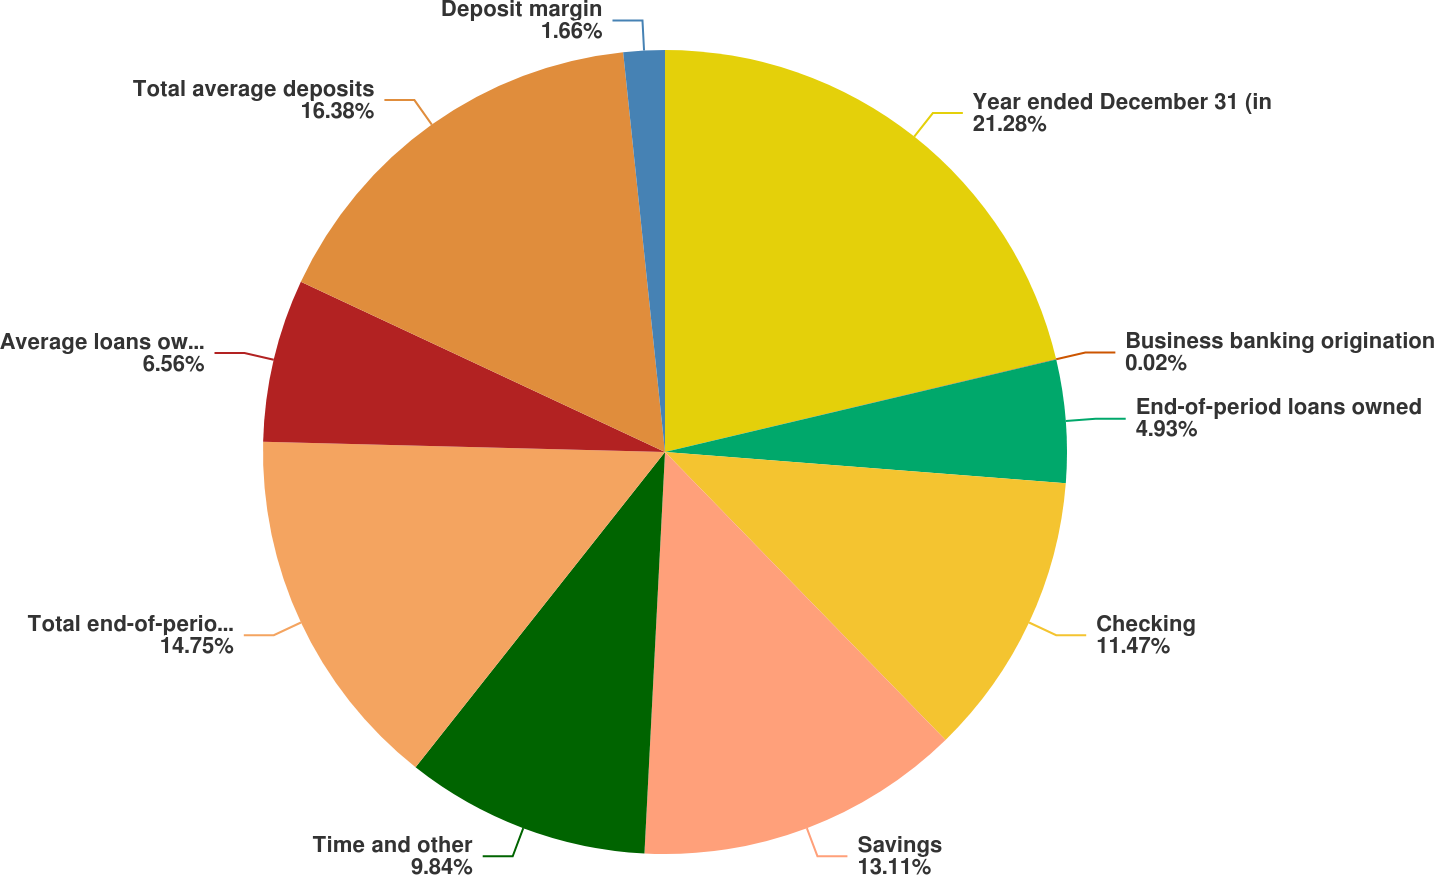Convert chart to OTSL. <chart><loc_0><loc_0><loc_500><loc_500><pie_chart><fcel>Year ended December 31 (in<fcel>Business banking origination<fcel>End-of-period loans owned<fcel>Checking<fcel>Savings<fcel>Time and other<fcel>Total end-of-period deposits<fcel>Average loans owned<fcel>Total average deposits<fcel>Deposit margin<nl><fcel>21.29%<fcel>0.02%<fcel>4.93%<fcel>11.47%<fcel>13.11%<fcel>9.84%<fcel>14.75%<fcel>6.56%<fcel>16.38%<fcel>1.66%<nl></chart> 